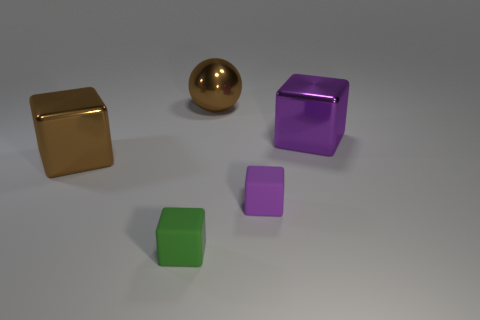Subtract all green cubes. How many cubes are left? 3 Add 1 shiny spheres. How many objects exist? 6 Subtract all blue cubes. Subtract all yellow balls. How many cubes are left? 4 Subtract all balls. How many objects are left? 4 Subtract 1 green cubes. How many objects are left? 4 Subtract all big brown balls. Subtract all purple things. How many objects are left? 2 Add 3 blocks. How many blocks are left? 7 Add 2 metal spheres. How many metal spheres exist? 3 